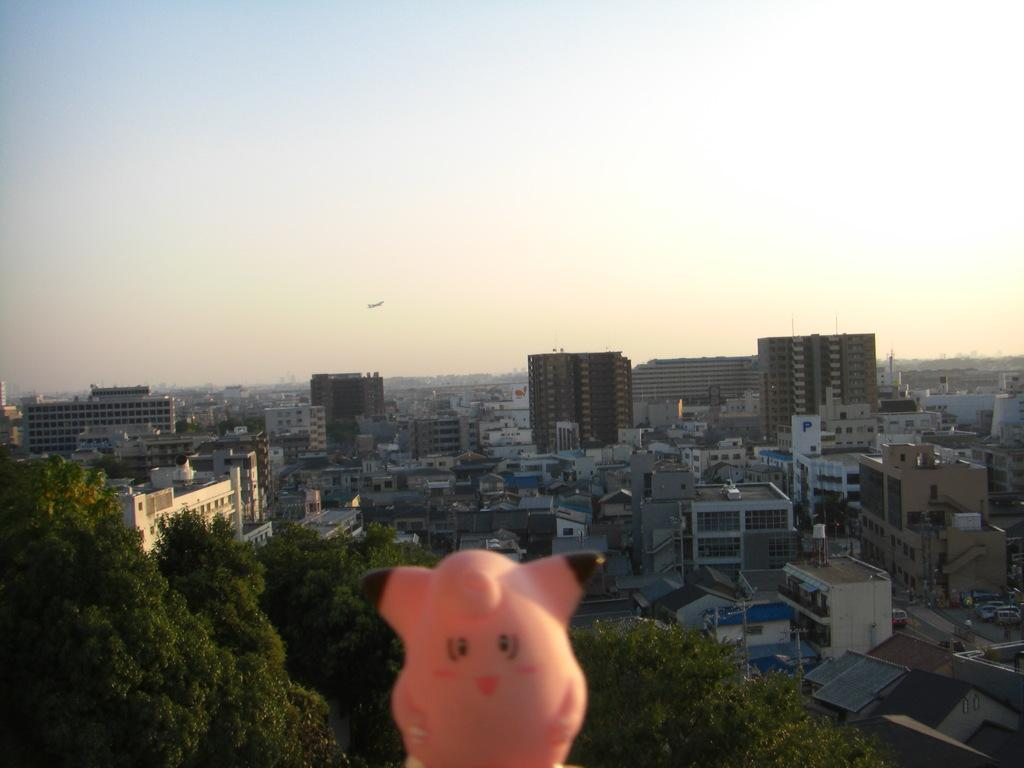What object in the image is designed for play or entertainment? There is a toy in the image. What type of natural elements can be seen in the image? There are trees in the image. What type of man-made structures are visible in the image? There are buildings in the image. What part of the natural environment is visible in the background of the image? The sky is visible in the background of the image. In which direction does the straw point in the image? There is no straw visible in the image. What type of approval is being sought in the image? There is no indication of any approval process or request in the image. 